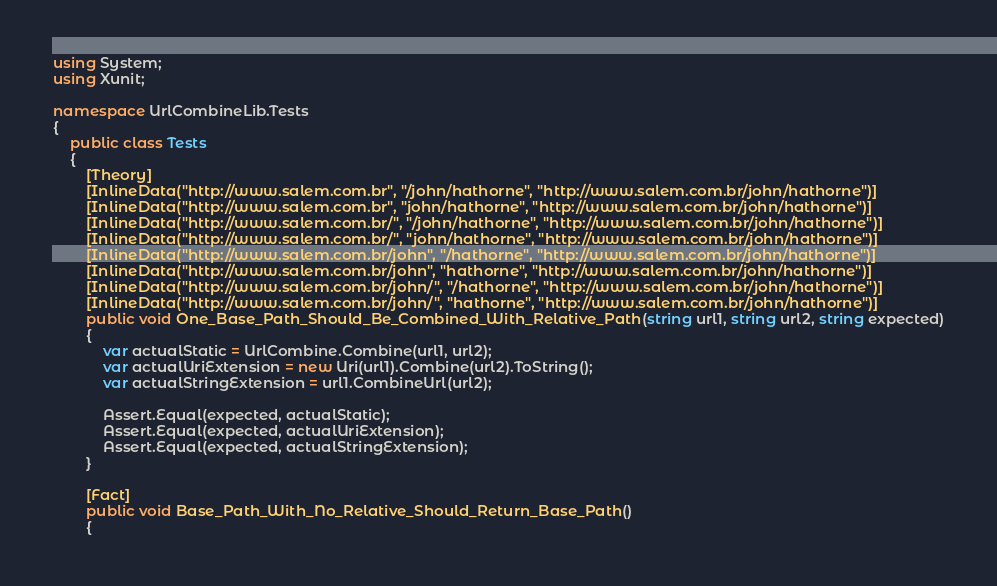Convert code to text. <code><loc_0><loc_0><loc_500><loc_500><_C#_>using System;
using Xunit;

namespace UrlCombineLib.Tests
{
    public class Tests
    {
        [Theory]
        [InlineData("http://www.salem.com.br", "/john/hathorne", "http://www.salem.com.br/john/hathorne")]
        [InlineData("http://www.salem.com.br", "john/hathorne", "http://www.salem.com.br/john/hathorne")]
        [InlineData("http://www.salem.com.br/", "/john/hathorne", "http://www.salem.com.br/john/hathorne")]
        [InlineData("http://www.salem.com.br/", "john/hathorne", "http://www.salem.com.br/john/hathorne")]
        [InlineData("http://www.salem.com.br/john", "/hathorne", "http://www.salem.com.br/john/hathorne")]
        [InlineData("http://www.salem.com.br/john", "hathorne", "http://www.salem.com.br/john/hathorne")]
        [InlineData("http://www.salem.com.br/john/", "/hathorne", "http://www.salem.com.br/john/hathorne")]
        [InlineData("http://www.salem.com.br/john/", "hathorne", "http://www.salem.com.br/john/hathorne")]
        public void One_Base_Path_Should_Be_Combined_With_Relative_Path(string url1, string url2, string expected)
        {
            var actualStatic = UrlCombine.Combine(url1, url2);
            var actualUriExtension = new Uri(url1).Combine(url2).ToString();
            var actualStringExtension = url1.CombineUrl(url2);

            Assert.Equal(expected, actualStatic);
            Assert.Equal(expected, actualUriExtension);
            Assert.Equal(expected, actualStringExtension);
        }

        [Fact]
        public void Base_Path_With_No_Relative_Should_Return_Base_Path()
        {</code> 